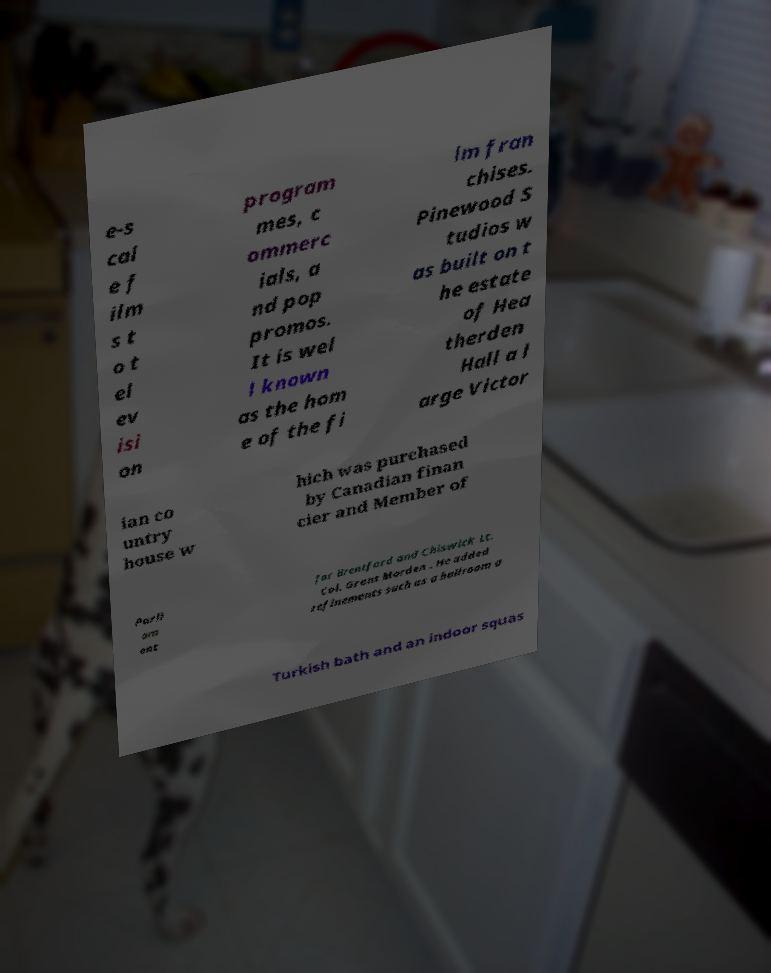Please identify and transcribe the text found in this image. e-s cal e f ilm s t o t el ev isi on program mes, c ommerc ials, a nd pop promos. It is wel l known as the hom e of the fi lm fran chises. Pinewood S tudios w as built on t he estate of Hea therden Hall a l arge Victor ian co untry house w hich was purchased by Canadian finan cier and Member of Parli am ent for Brentford and Chiswick Lt. Col. Grant Morden . He added refinements such as a ballroom a Turkish bath and an indoor squas 